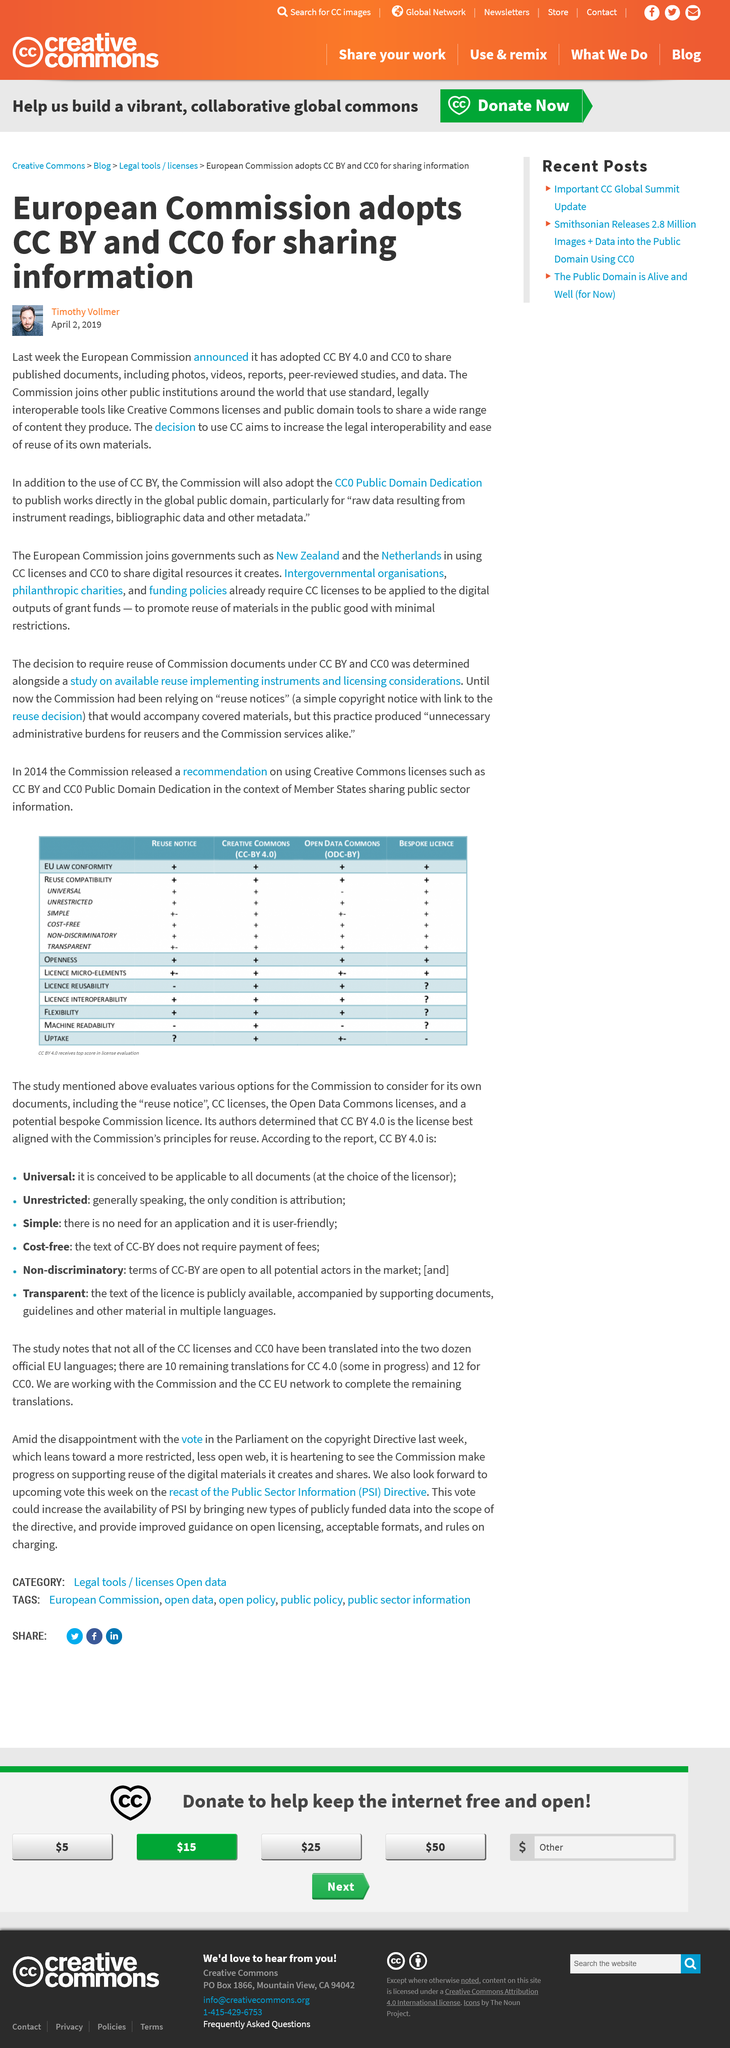Mention a couple of crucial points in this snapshot. The decision to use Creative Commons (CC) was made to increase the legal interoperability and ease of reuse of the European Commission's own materials. The European Commission has decided to adopt the Creative Commons Attribution (CC BY) license and the CC0 tool for sharing information. The name of the man in the small portrait below the title is Timothy Vollmer. 